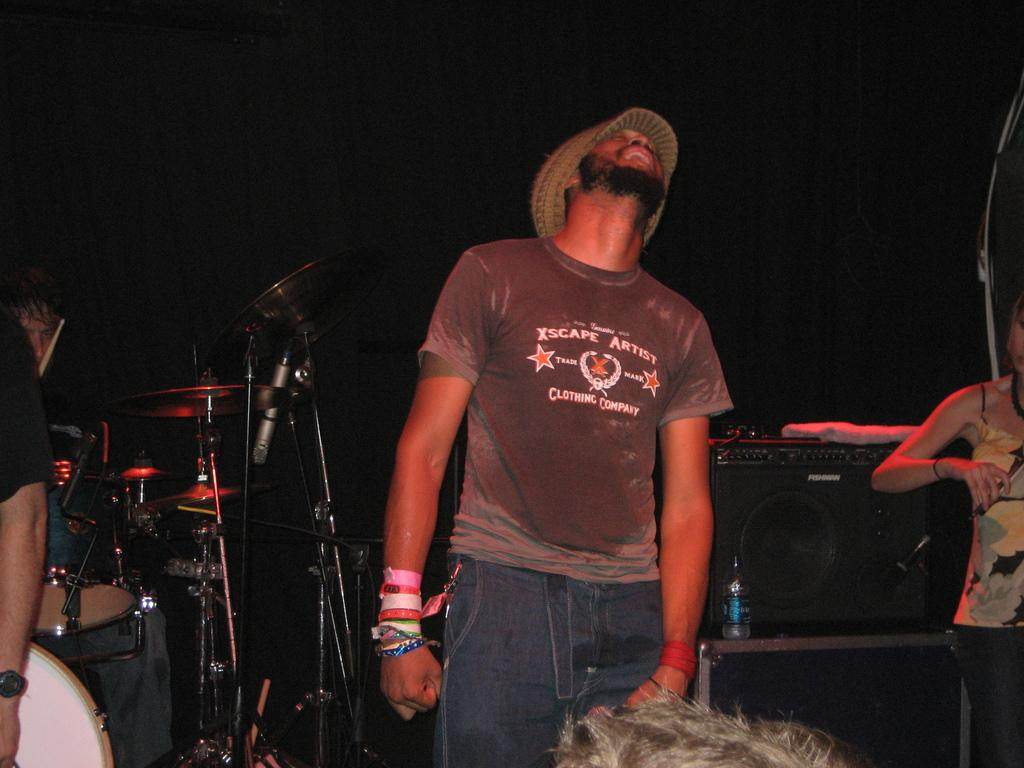Who is the main subject in the image? There is a man in the center of the image. What is the man doing in the image? The man is looking upward. What else can be seen in the image besides the man? There are musical instruments and other people present in the image. What type of cork can be seen in the image? There is no cork present in the image. How many kilograms of butter are visible in the image? There is no butter present in the image. 